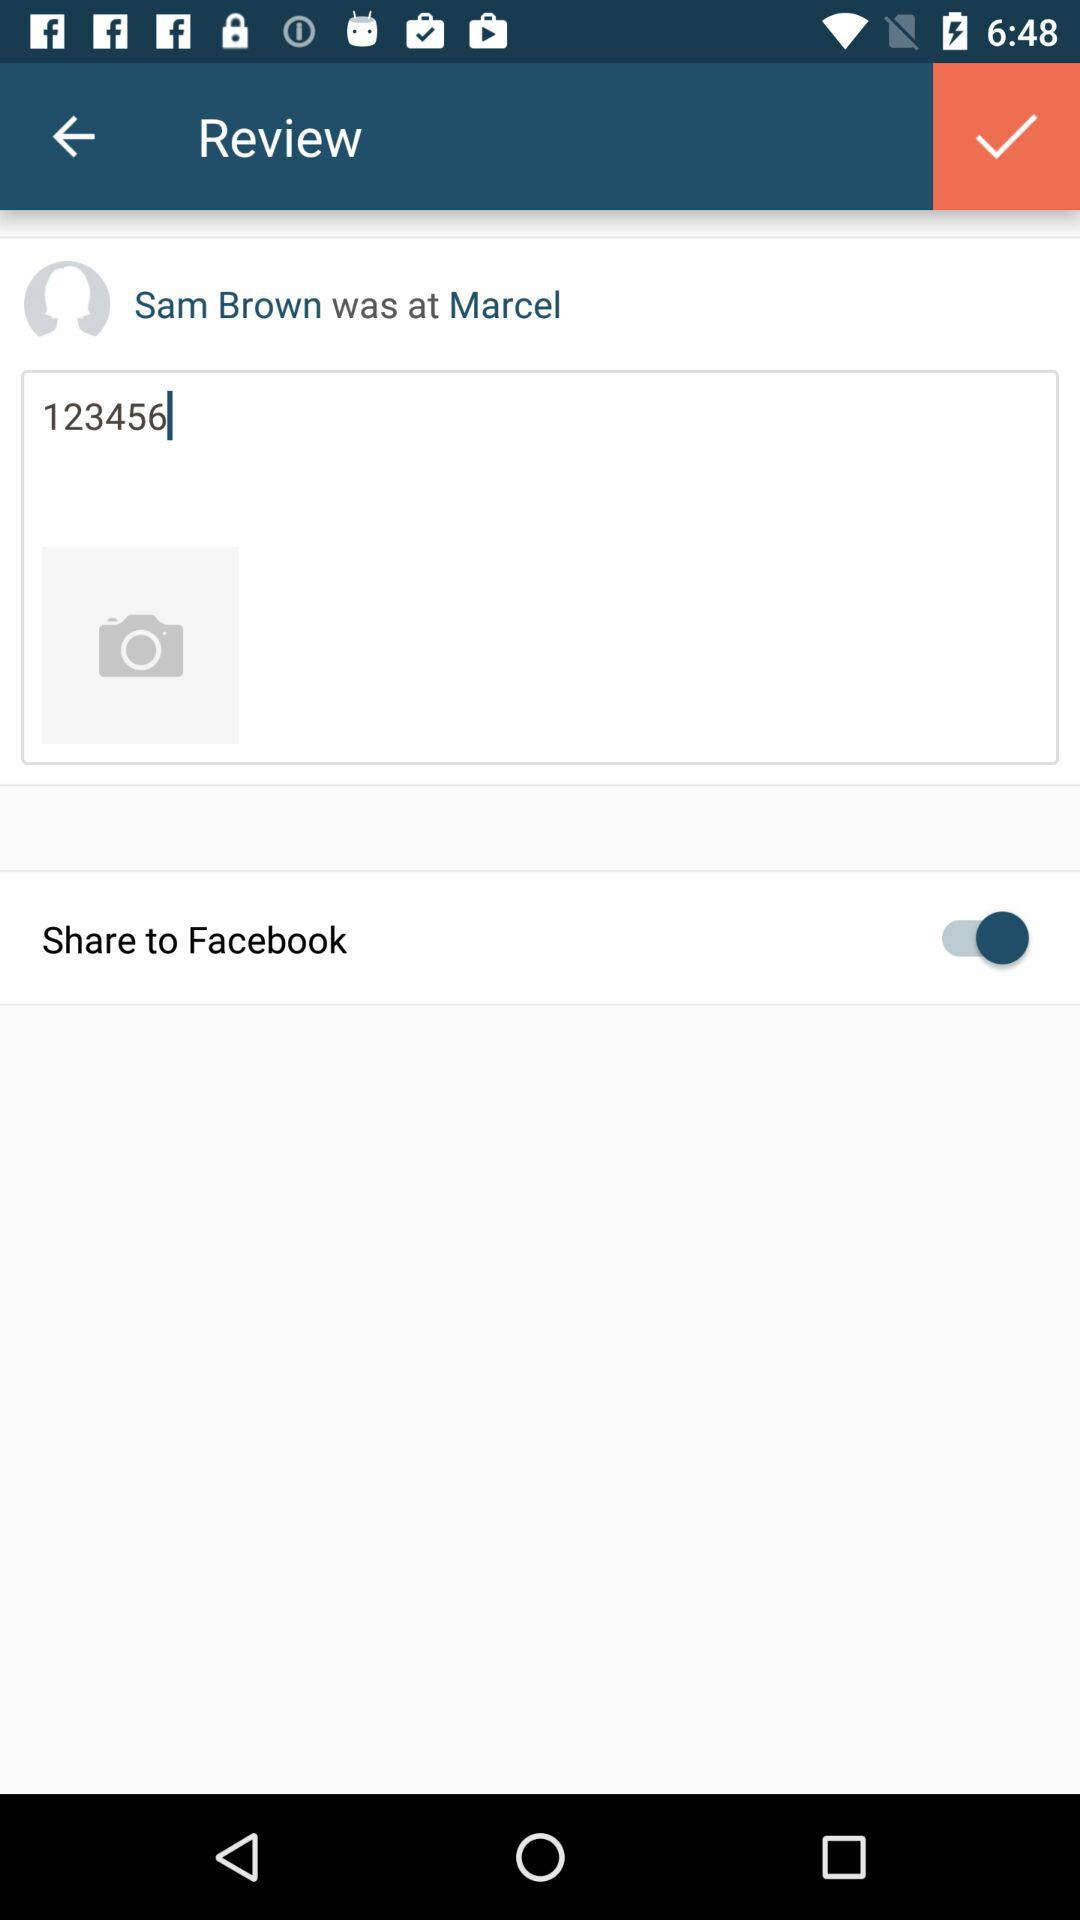What's the status of "Share to Facebook"? The status is "on". 